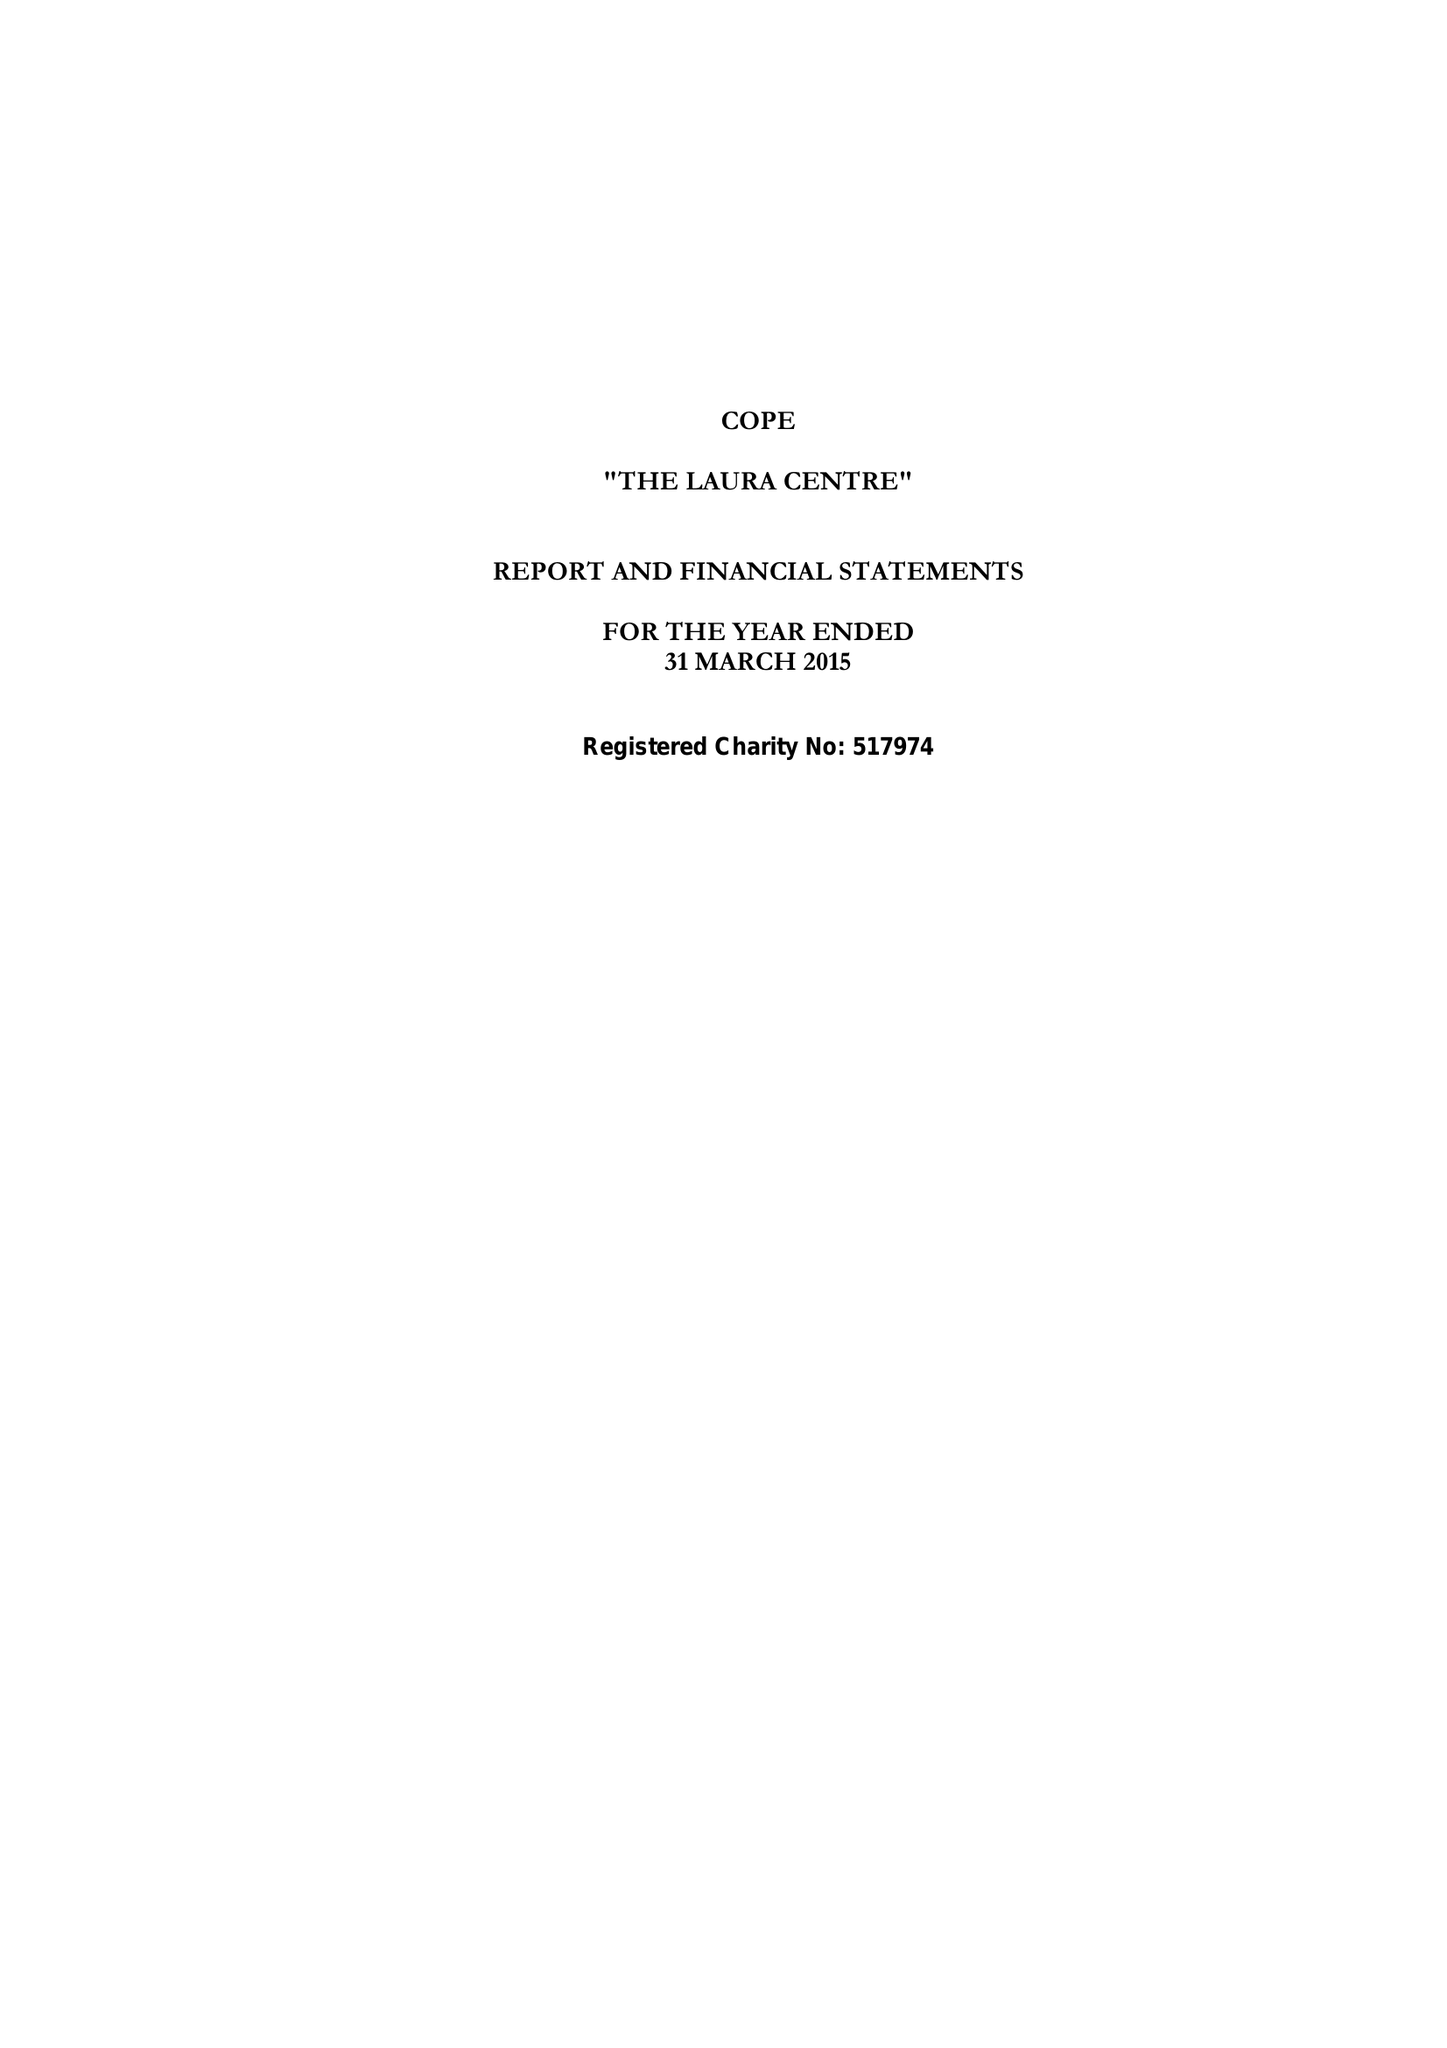What is the value for the address__street_line?
Answer the question using a single word or phrase. 4-6 TOWER STREET 